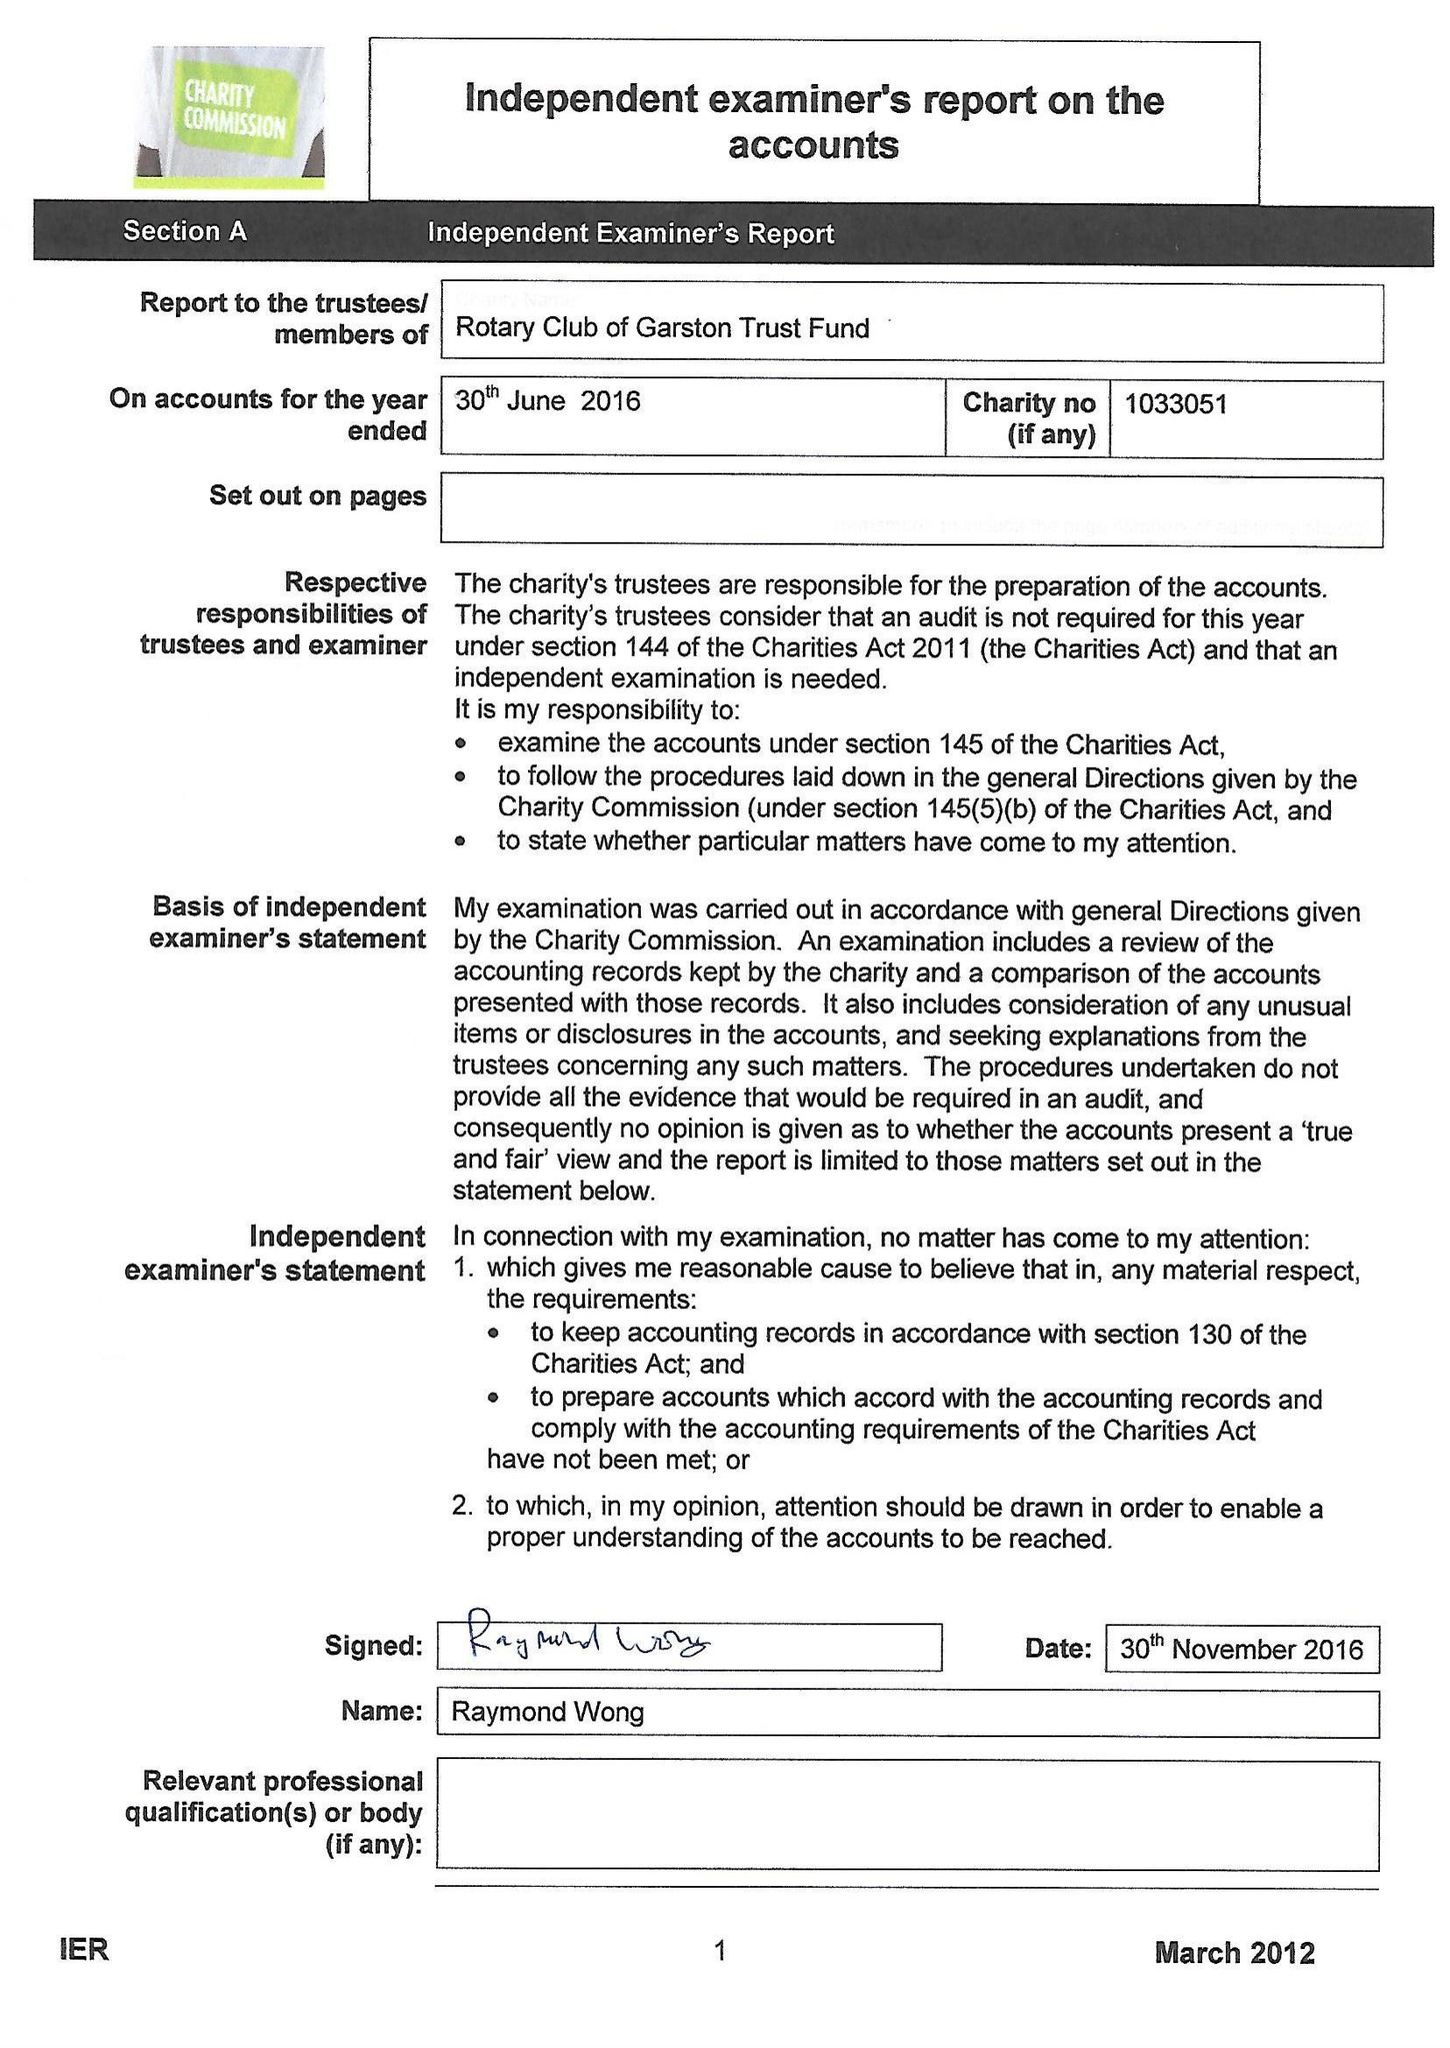What is the value for the income_annually_in_british_pounds?
Answer the question using a single word or phrase. 41473.00 